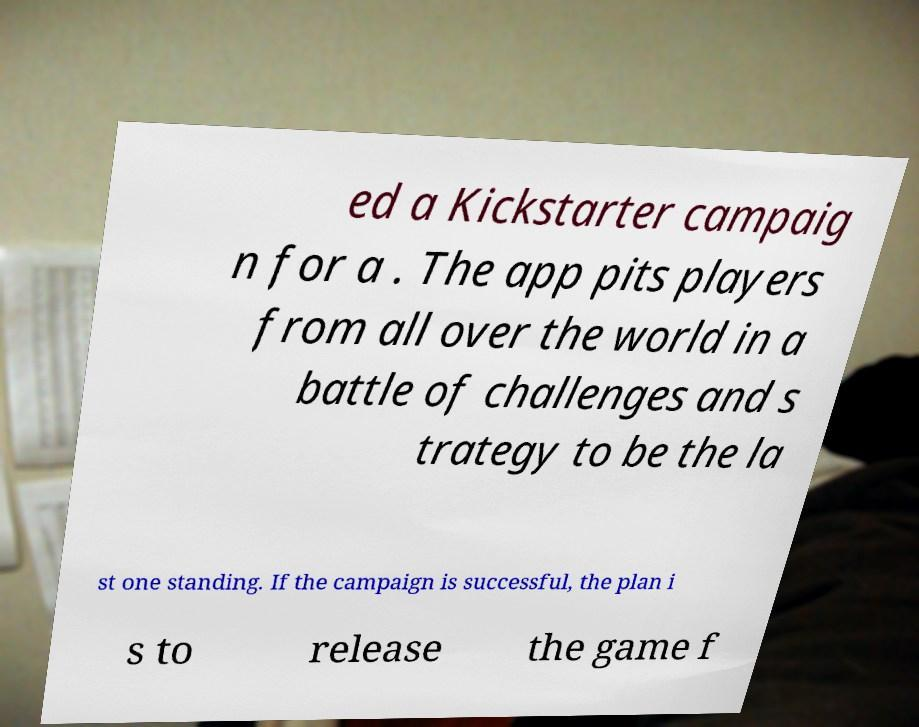Can you accurately transcribe the text from the provided image for me? ed a Kickstarter campaig n for a . The app pits players from all over the world in a battle of challenges and s trategy to be the la st one standing. If the campaign is successful, the plan i s to release the game f 